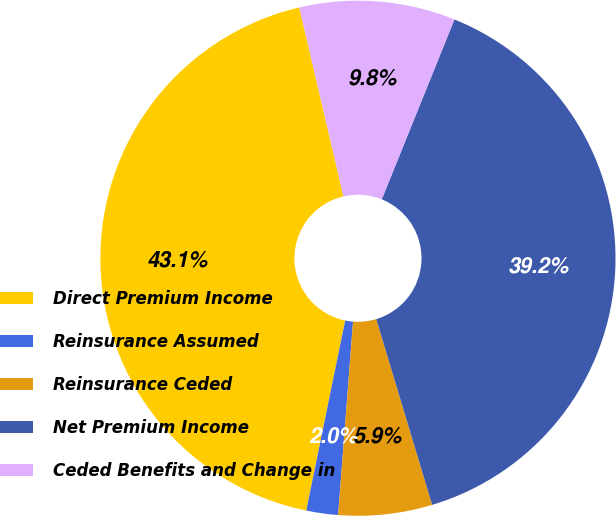<chart> <loc_0><loc_0><loc_500><loc_500><pie_chart><fcel>Direct Premium Income<fcel>Reinsurance Assumed<fcel>Reinsurance Ceded<fcel>Net Premium Income<fcel>Ceded Benefits and Change in<nl><fcel>43.13%<fcel>1.99%<fcel>5.88%<fcel>39.24%<fcel>9.77%<nl></chart> 